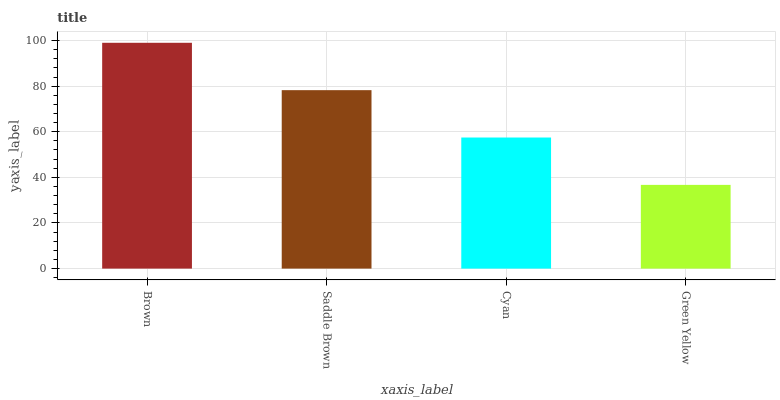Is Saddle Brown the minimum?
Answer yes or no. No. Is Saddle Brown the maximum?
Answer yes or no. No. Is Brown greater than Saddle Brown?
Answer yes or no. Yes. Is Saddle Brown less than Brown?
Answer yes or no. Yes. Is Saddle Brown greater than Brown?
Answer yes or no. No. Is Brown less than Saddle Brown?
Answer yes or no. No. Is Saddle Brown the high median?
Answer yes or no. Yes. Is Cyan the low median?
Answer yes or no. Yes. Is Brown the high median?
Answer yes or no. No. Is Brown the low median?
Answer yes or no. No. 